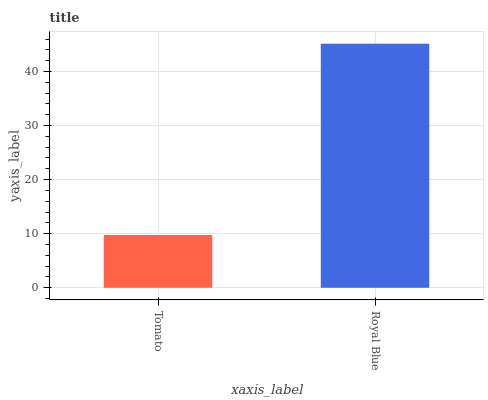Is Tomato the minimum?
Answer yes or no. Yes. Is Royal Blue the maximum?
Answer yes or no. Yes. Is Royal Blue the minimum?
Answer yes or no. No. Is Royal Blue greater than Tomato?
Answer yes or no. Yes. Is Tomato less than Royal Blue?
Answer yes or no. Yes. Is Tomato greater than Royal Blue?
Answer yes or no. No. Is Royal Blue less than Tomato?
Answer yes or no. No. Is Royal Blue the high median?
Answer yes or no. Yes. Is Tomato the low median?
Answer yes or no. Yes. Is Tomato the high median?
Answer yes or no. No. Is Royal Blue the low median?
Answer yes or no. No. 